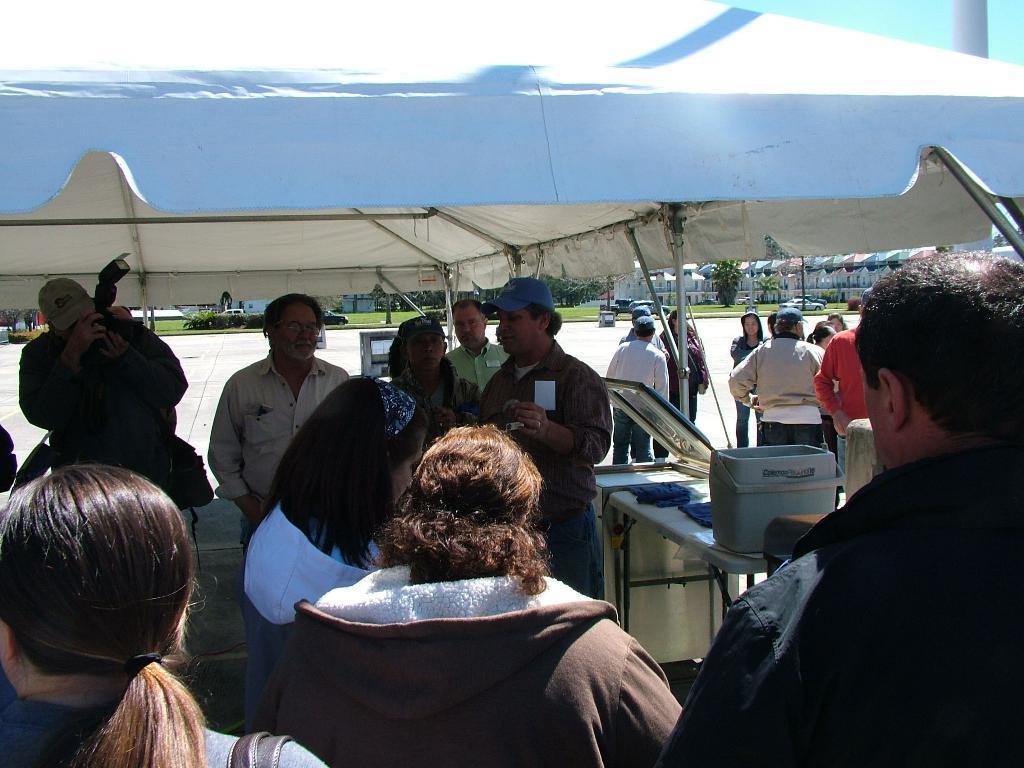Could you give a brief overview of what you see in this image? Here we can see group of people. There are tents. This is a table. On the table there is a box. In the background we can see trees, grass, and houses. 